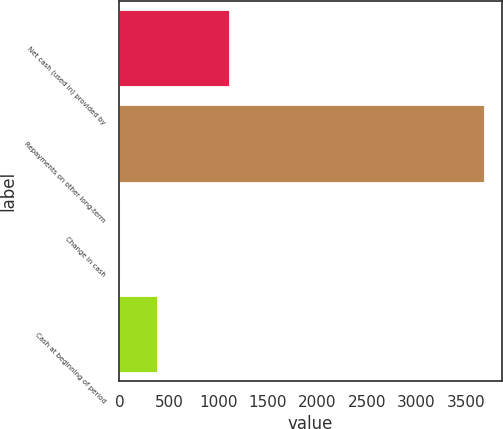Convert chart to OTSL. <chart><loc_0><loc_0><loc_500><loc_500><bar_chart><fcel>Net cash (used in) provided by<fcel>Repayments on other long-term<fcel>Change in cash<fcel>Cash at beginning of period<nl><fcel>1109.9<fcel>3681<fcel>8<fcel>375.3<nl></chart> 